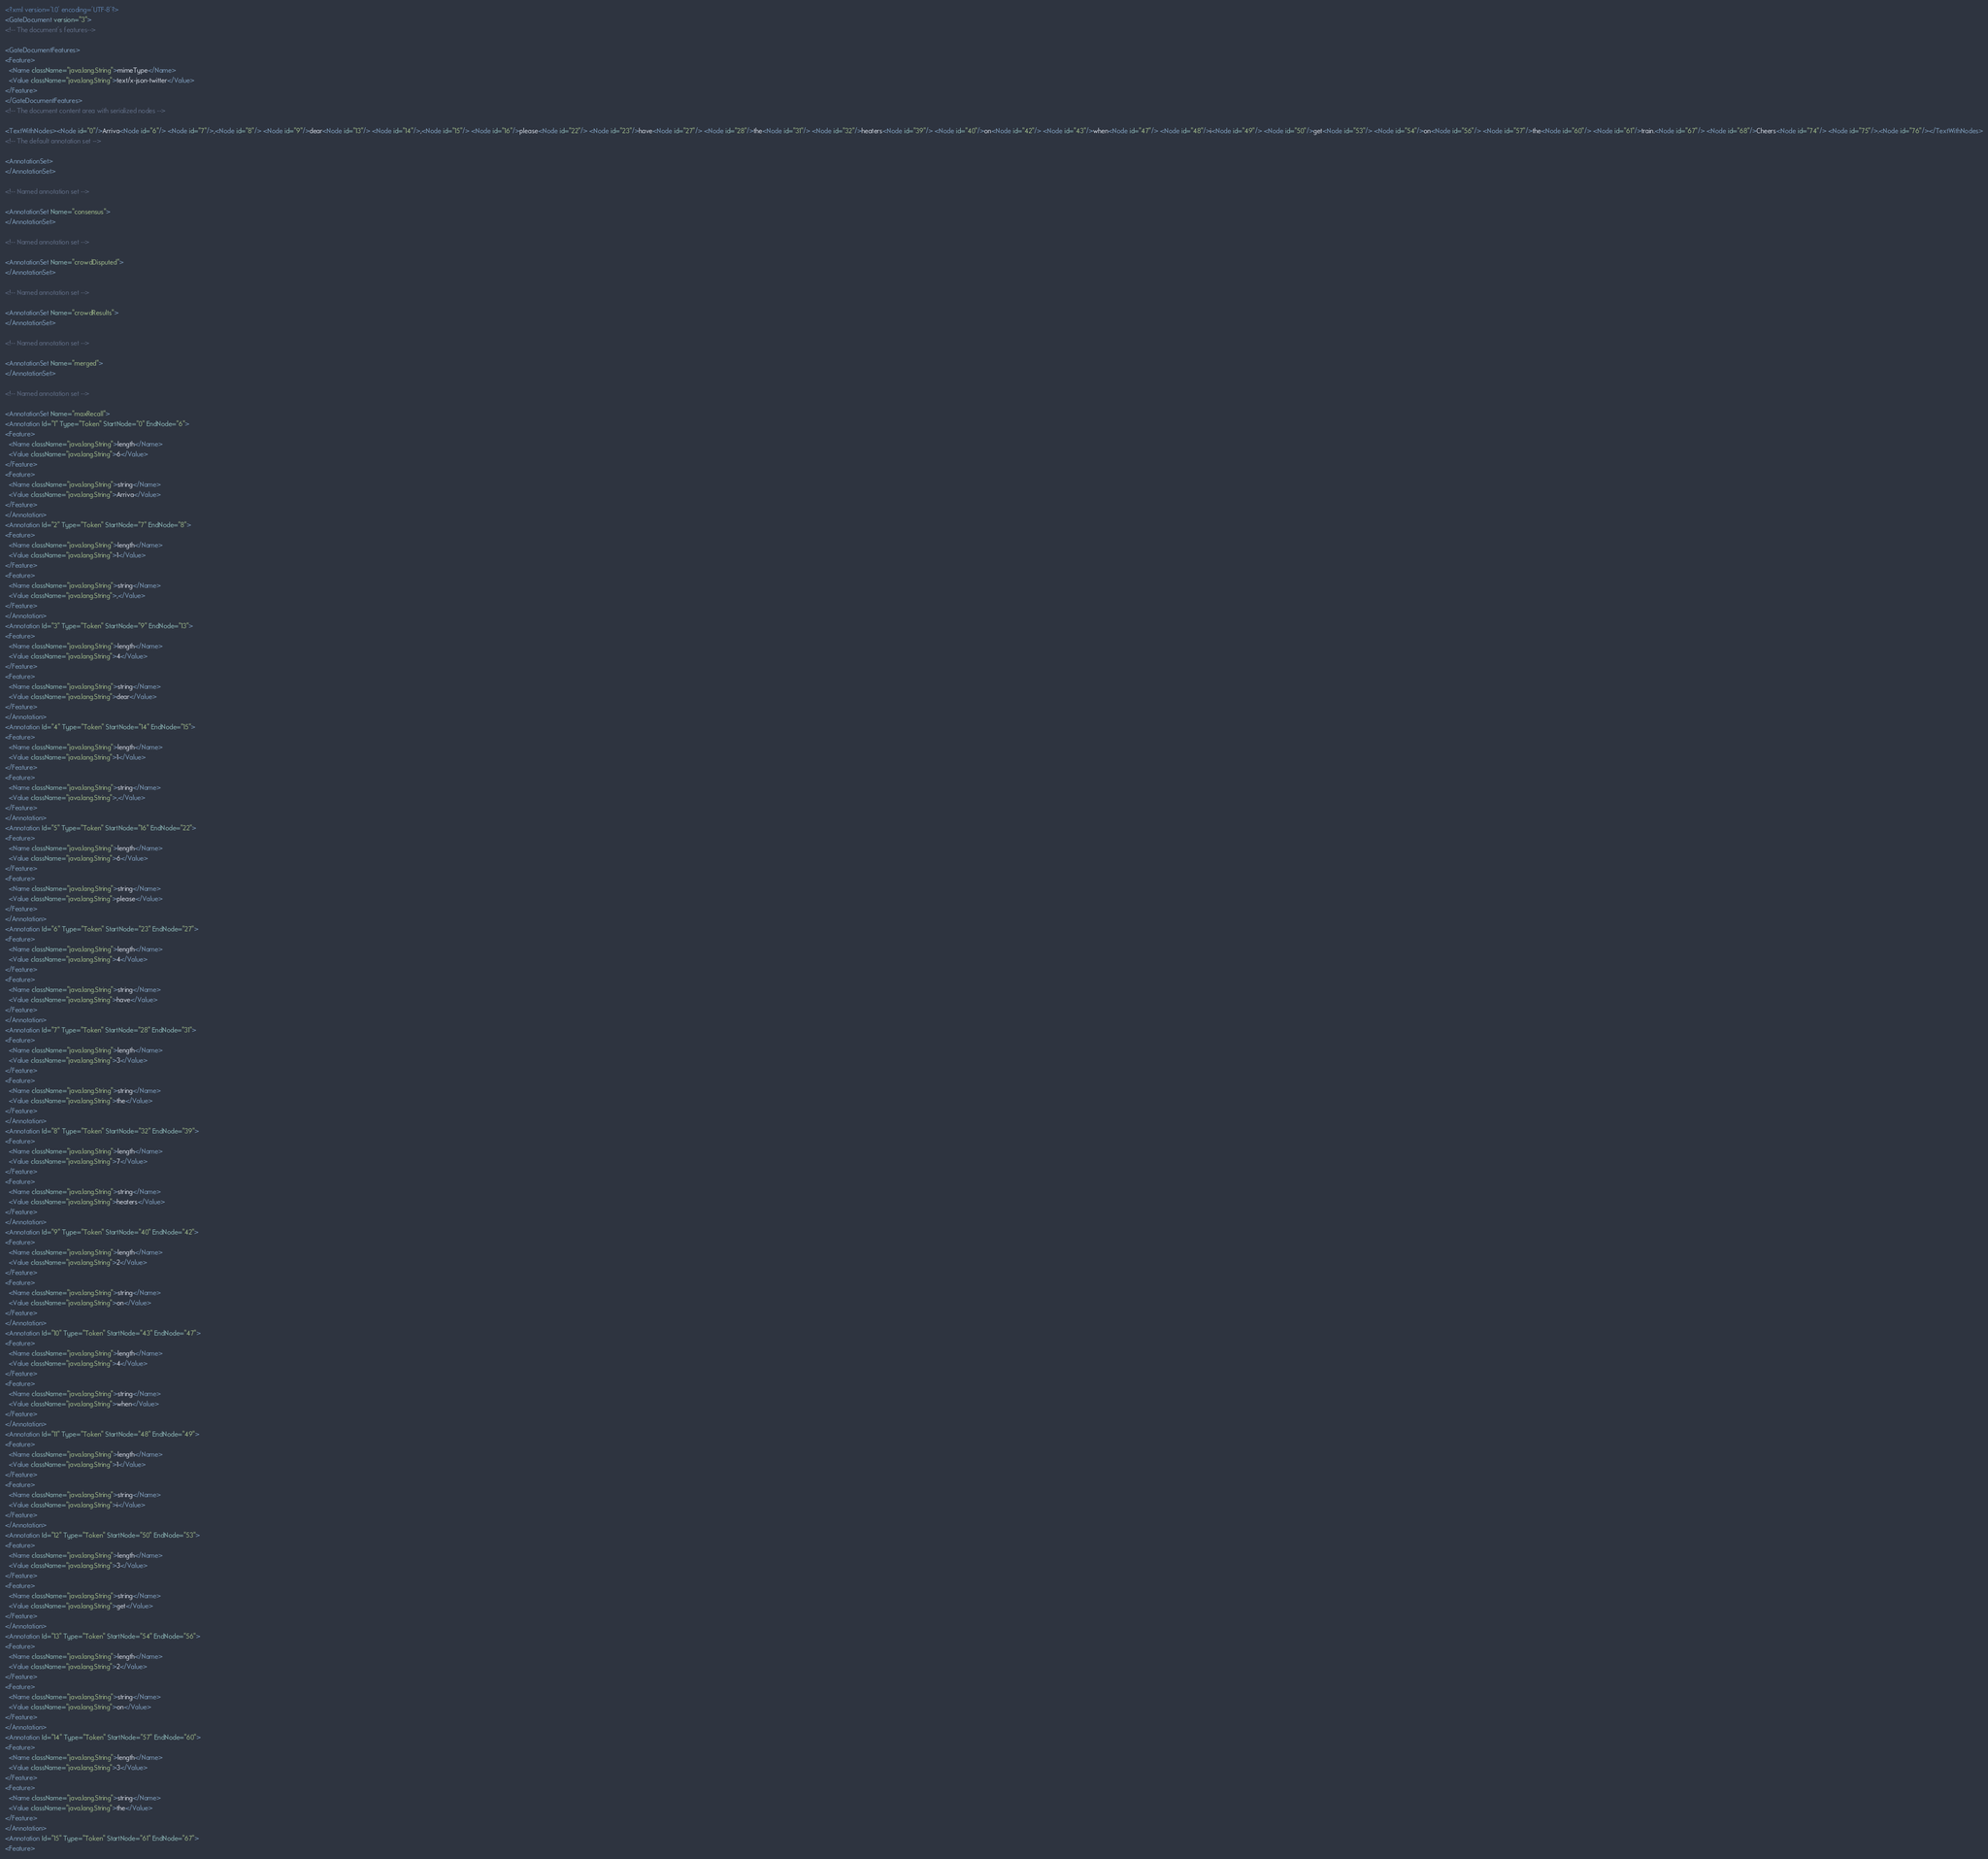Convert code to text. <code><loc_0><loc_0><loc_500><loc_500><_XML_><?xml version='1.0' encoding='UTF-8'?>
<GateDocument version="3">
<!-- The document's features-->

<GateDocumentFeatures>
<Feature>
  <Name className="java.lang.String">mimeType</Name>
  <Value className="java.lang.String">text/x-json-twitter</Value>
</Feature>
</GateDocumentFeatures>
<!-- The document content area with serialized nodes -->

<TextWithNodes><Node id="0"/>Arriva<Node id="6"/> <Node id="7"/>,<Node id="8"/> <Node id="9"/>dear<Node id="13"/> <Node id="14"/>,<Node id="15"/> <Node id="16"/>please<Node id="22"/> <Node id="23"/>have<Node id="27"/> <Node id="28"/>the<Node id="31"/> <Node id="32"/>heaters<Node id="39"/> <Node id="40"/>on<Node id="42"/> <Node id="43"/>when<Node id="47"/> <Node id="48"/>i<Node id="49"/> <Node id="50"/>get<Node id="53"/> <Node id="54"/>on<Node id="56"/> <Node id="57"/>the<Node id="60"/> <Node id="61"/>train.<Node id="67"/> <Node id="68"/>Cheers<Node id="74"/> <Node id="75"/>.<Node id="76"/></TextWithNodes>
<!-- The default annotation set -->

<AnnotationSet>
</AnnotationSet>

<!-- Named annotation set -->

<AnnotationSet Name="consensus">
</AnnotationSet>

<!-- Named annotation set -->

<AnnotationSet Name="crowdDisputed">
</AnnotationSet>

<!-- Named annotation set -->

<AnnotationSet Name="crowdResults">
</AnnotationSet>

<!-- Named annotation set -->

<AnnotationSet Name="merged">
</AnnotationSet>

<!-- Named annotation set -->

<AnnotationSet Name="maxRecall">
<Annotation Id="1" Type="Token" StartNode="0" EndNode="6">
<Feature>
  <Name className="java.lang.String">length</Name>
  <Value className="java.lang.String">6</Value>
</Feature>
<Feature>
  <Name className="java.lang.String">string</Name>
  <Value className="java.lang.String">Arriva</Value>
</Feature>
</Annotation>
<Annotation Id="2" Type="Token" StartNode="7" EndNode="8">
<Feature>
  <Name className="java.lang.String">length</Name>
  <Value className="java.lang.String">1</Value>
</Feature>
<Feature>
  <Name className="java.lang.String">string</Name>
  <Value className="java.lang.String">,</Value>
</Feature>
</Annotation>
<Annotation Id="3" Type="Token" StartNode="9" EndNode="13">
<Feature>
  <Name className="java.lang.String">length</Name>
  <Value className="java.lang.String">4</Value>
</Feature>
<Feature>
  <Name className="java.lang.String">string</Name>
  <Value className="java.lang.String">dear</Value>
</Feature>
</Annotation>
<Annotation Id="4" Type="Token" StartNode="14" EndNode="15">
<Feature>
  <Name className="java.lang.String">length</Name>
  <Value className="java.lang.String">1</Value>
</Feature>
<Feature>
  <Name className="java.lang.String">string</Name>
  <Value className="java.lang.String">,</Value>
</Feature>
</Annotation>
<Annotation Id="5" Type="Token" StartNode="16" EndNode="22">
<Feature>
  <Name className="java.lang.String">length</Name>
  <Value className="java.lang.String">6</Value>
</Feature>
<Feature>
  <Name className="java.lang.String">string</Name>
  <Value className="java.lang.String">please</Value>
</Feature>
</Annotation>
<Annotation Id="6" Type="Token" StartNode="23" EndNode="27">
<Feature>
  <Name className="java.lang.String">length</Name>
  <Value className="java.lang.String">4</Value>
</Feature>
<Feature>
  <Name className="java.lang.String">string</Name>
  <Value className="java.lang.String">have</Value>
</Feature>
</Annotation>
<Annotation Id="7" Type="Token" StartNode="28" EndNode="31">
<Feature>
  <Name className="java.lang.String">length</Name>
  <Value className="java.lang.String">3</Value>
</Feature>
<Feature>
  <Name className="java.lang.String">string</Name>
  <Value className="java.lang.String">the</Value>
</Feature>
</Annotation>
<Annotation Id="8" Type="Token" StartNode="32" EndNode="39">
<Feature>
  <Name className="java.lang.String">length</Name>
  <Value className="java.lang.String">7</Value>
</Feature>
<Feature>
  <Name className="java.lang.String">string</Name>
  <Value className="java.lang.String">heaters</Value>
</Feature>
</Annotation>
<Annotation Id="9" Type="Token" StartNode="40" EndNode="42">
<Feature>
  <Name className="java.lang.String">length</Name>
  <Value className="java.lang.String">2</Value>
</Feature>
<Feature>
  <Name className="java.lang.String">string</Name>
  <Value className="java.lang.String">on</Value>
</Feature>
</Annotation>
<Annotation Id="10" Type="Token" StartNode="43" EndNode="47">
<Feature>
  <Name className="java.lang.String">length</Name>
  <Value className="java.lang.String">4</Value>
</Feature>
<Feature>
  <Name className="java.lang.String">string</Name>
  <Value className="java.lang.String">when</Value>
</Feature>
</Annotation>
<Annotation Id="11" Type="Token" StartNode="48" EndNode="49">
<Feature>
  <Name className="java.lang.String">length</Name>
  <Value className="java.lang.String">1</Value>
</Feature>
<Feature>
  <Name className="java.lang.String">string</Name>
  <Value className="java.lang.String">i</Value>
</Feature>
</Annotation>
<Annotation Id="12" Type="Token" StartNode="50" EndNode="53">
<Feature>
  <Name className="java.lang.String">length</Name>
  <Value className="java.lang.String">3</Value>
</Feature>
<Feature>
  <Name className="java.lang.String">string</Name>
  <Value className="java.lang.String">get</Value>
</Feature>
</Annotation>
<Annotation Id="13" Type="Token" StartNode="54" EndNode="56">
<Feature>
  <Name className="java.lang.String">length</Name>
  <Value className="java.lang.String">2</Value>
</Feature>
<Feature>
  <Name className="java.lang.String">string</Name>
  <Value className="java.lang.String">on</Value>
</Feature>
</Annotation>
<Annotation Id="14" Type="Token" StartNode="57" EndNode="60">
<Feature>
  <Name className="java.lang.String">length</Name>
  <Value className="java.lang.String">3</Value>
</Feature>
<Feature>
  <Name className="java.lang.String">string</Name>
  <Value className="java.lang.String">the</Value>
</Feature>
</Annotation>
<Annotation Id="15" Type="Token" StartNode="61" EndNode="67">
<Feature></code> 